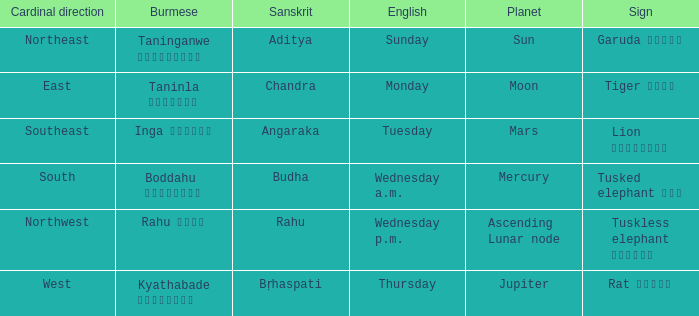State the name of day in english where cardinal direction is east Monday. 